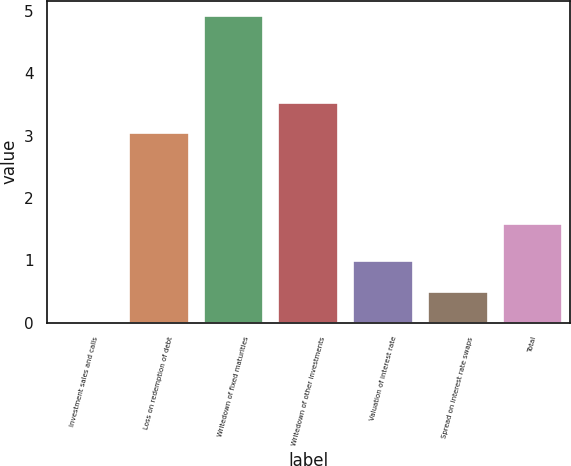Convert chart. <chart><loc_0><loc_0><loc_500><loc_500><bar_chart><fcel>Investment sales and calls<fcel>Loss on redemption of debt<fcel>Writedown of fixed maturities<fcel>Writedown of other investments<fcel>Valuation of interest rate<fcel>Spread on interest rate swaps<fcel>Total<nl><fcel>0.01<fcel>3.04<fcel>4.92<fcel>3.53<fcel>0.99<fcel>0.5<fcel>1.59<nl></chart> 